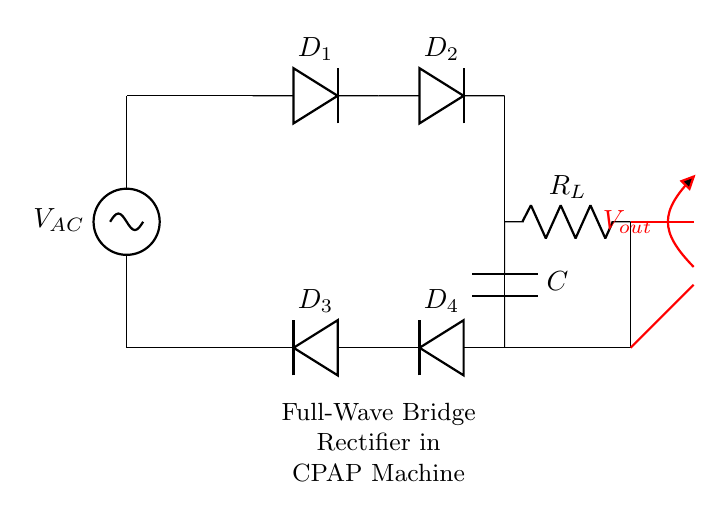What type of rectifier is shown in the circuit? The circuit is a full-wave bridge rectifier, which uses four diodes arranged in a bridge configuration to convert alternating current (AC) to direct current (DC).
Answer: full-wave bridge rectifier How many diodes are in the bridge rectifier? There are four diodes (D1, D2, D3, D4) present in the bridge rectifier setup, which allows it to conduct current during both halves of the AC cycle.
Answer: four What component smooths the output voltage? The capacitor (C) connected between the output and ground helps to smooth out the fluctuations in the output voltage, providing a more stable DC output.
Answer: capacitor What is the purpose of the load resistor in the circuit? The load resistor (R_L) represents the device or component that utilizes the output voltage from the rectifier. It determines the current flow through the circuit when the system is operational.
Answer: load resistor Explain how current flows in the bridge rectifier. During the positive half-cycle of the AC input, D1 and D2 conduct, allowing current to flow from the source through R_L to the capacitor, producing a positive output. During the negative half-cycle, D3 and D4 conduct, allowing current to still flow in the same direction through R_L to the capacitor, keeping the output positive. Hence, current flows in a unidirectional manner throughout the circuit during both cycles.
Answer: unidirectional 